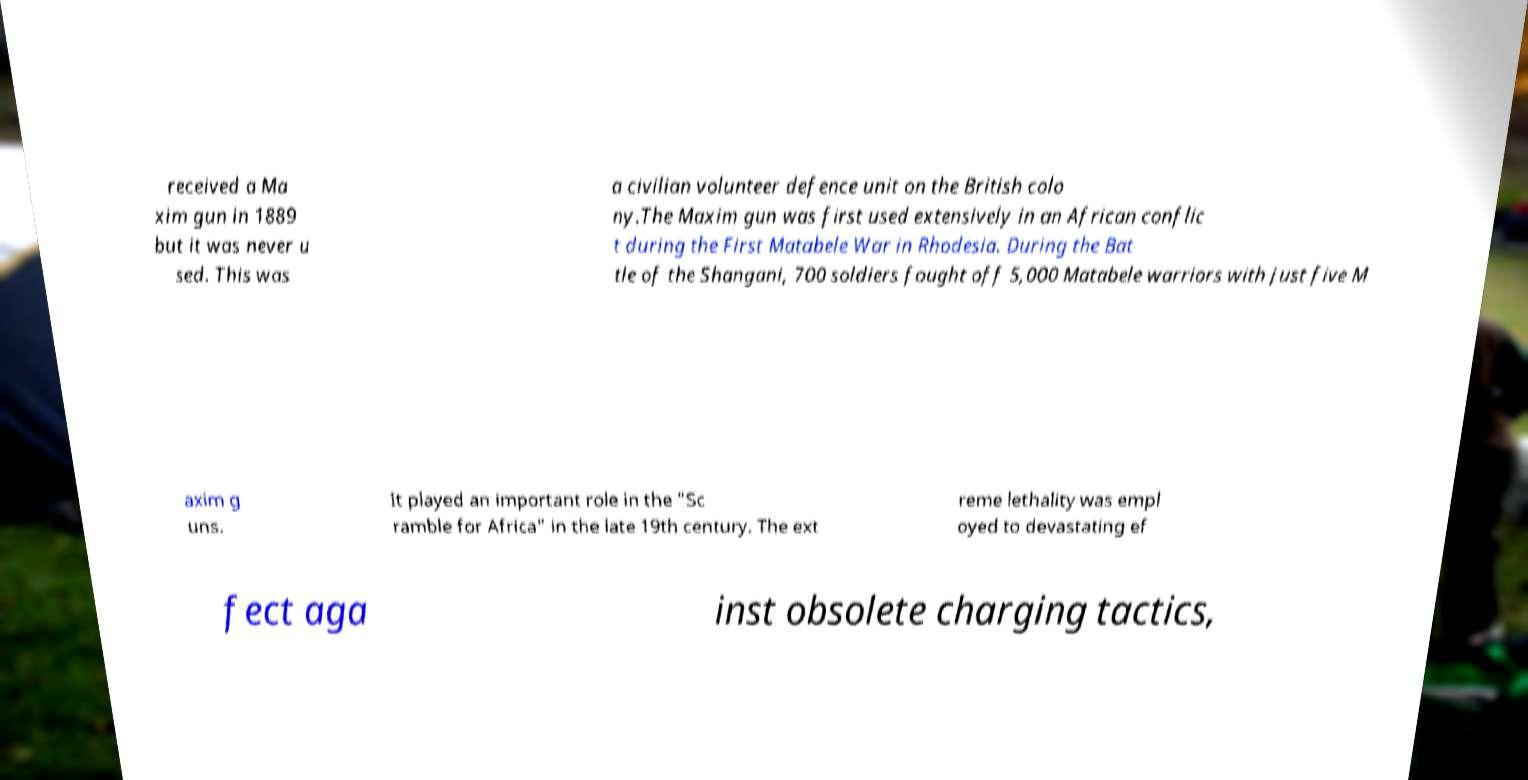Please read and relay the text visible in this image. What does it say? received a Ma xim gun in 1889 but it was never u sed. This was a civilian volunteer defence unit on the British colo ny.The Maxim gun was first used extensively in an African conflic t during the First Matabele War in Rhodesia. During the Bat tle of the Shangani, 700 soldiers fought off 5,000 Matabele warriors with just five M axim g uns. It played an important role in the "Sc ramble for Africa" in the late 19th century. The ext reme lethality was empl oyed to devastating ef fect aga inst obsolete charging tactics, 